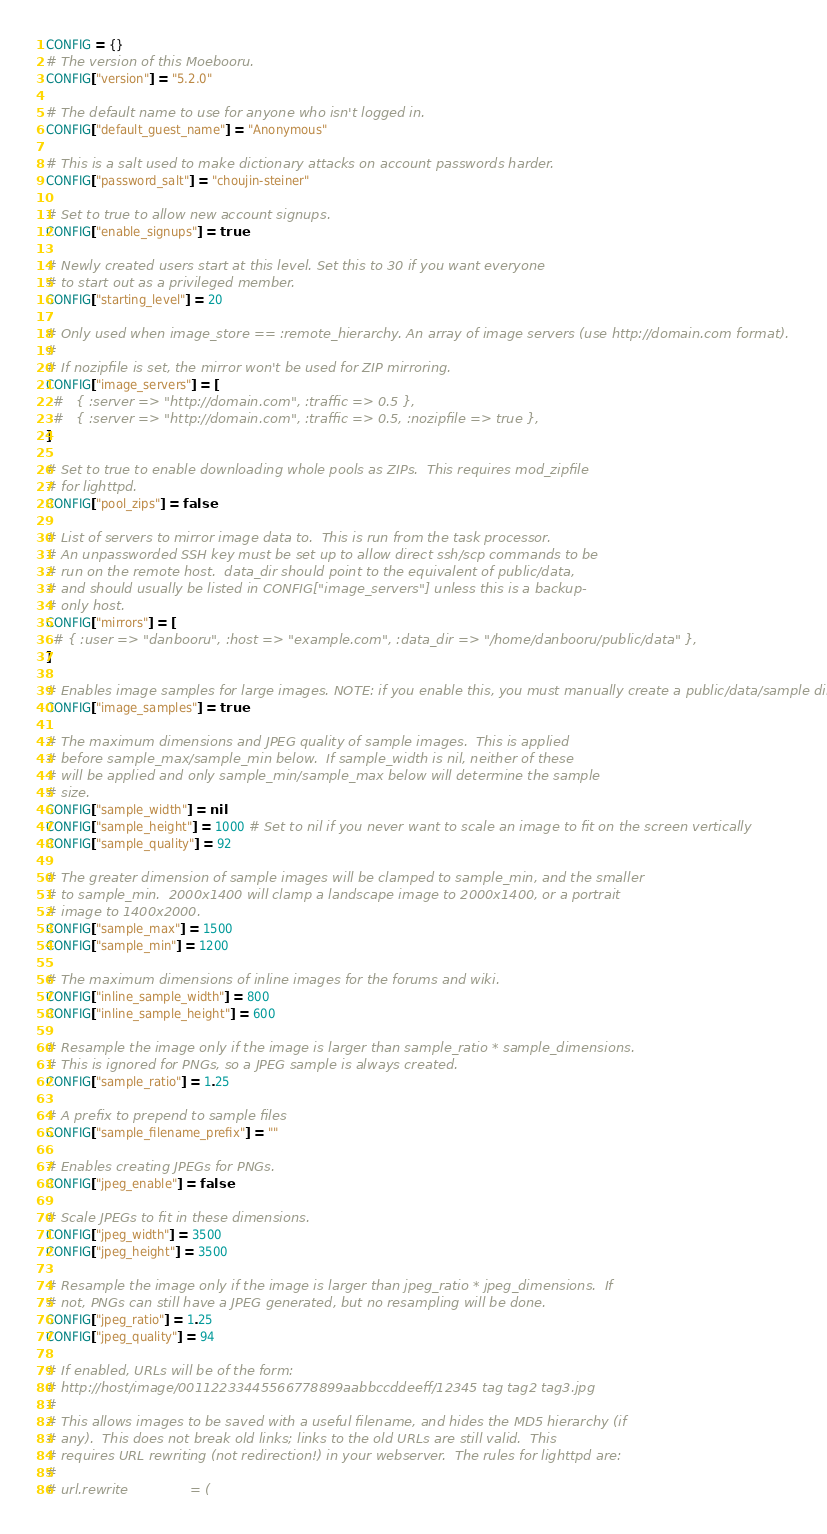<code> <loc_0><loc_0><loc_500><loc_500><_Ruby_>CONFIG = {}
# The version of this Moebooru.
CONFIG["version"] = "5.2.0"

# The default name to use for anyone who isn't logged in.
CONFIG["default_guest_name"] = "Anonymous"

# This is a salt used to make dictionary attacks on account passwords harder.
CONFIG["password_salt"] = "choujin-steiner"

# Set to true to allow new account signups.
CONFIG["enable_signups"] = true

# Newly created users start at this level. Set this to 30 if you want everyone
# to start out as a privileged member.
CONFIG["starting_level"] = 20

# Only used when image_store == :remote_hierarchy. An array of image servers (use http://domain.com format).
#
# If nozipfile is set, the mirror won't be used for ZIP mirroring.
CONFIG["image_servers"] = [
  #	{ :server => "http://domain.com", :traffic => 0.5 },
  #	{ :server => "http://domain.com", :traffic => 0.5, :nozipfile => true },
]

# Set to true to enable downloading whole pools as ZIPs.  This requires mod_zipfile
# for lighttpd.
CONFIG["pool_zips"] = false

# List of servers to mirror image data to.  This is run from the task processor.
# An unpassworded SSH key must be set up to allow direct ssh/scp commands to be
# run on the remote host.  data_dir should point to the equivalent of public/data,
# and should usually be listed in CONFIG["image_servers"] unless this is a backup-
# only host.
CONFIG["mirrors"] = [
  # { :user => "danbooru", :host => "example.com", :data_dir => "/home/danbooru/public/data" },
]

# Enables image samples for large images. NOTE: if you enable this, you must manually create a public/data/sample directory.
CONFIG["image_samples"] = true

# The maximum dimensions and JPEG quality of sample images.  This is applied
# before sample_max/sample_min below.  If sample_width is nil, neither of these
# will be applied and only sample_min/sample_max below will determine the sample
# size.
CONFIG["sample_width"] = nil
CONFIG["sample_height"] = 1000 # Set to nil if you never want to scale an image to fit on the screen vertically
CONFIG["sample_quality"] = 92

# The greater dimension of sample images will be clamped to sample_min, and the smaller
# to sample_min.  2000x1400 will clamp a landscape image to 2000x1400, or a portrait
# image to 1400x2000.
CONFIG["sample_max"] = 1500
CONFIG["sample_min"] = 1200

# The maximum dimensions of inline images for the forums and wiki.
CONFIG["inline_sample_width"] = 800
CONFIG["inline_sample_height"] = 600

# Resample the image only if the image is larger than sample_ratio * sample_dimensions.
# This is ignored for PNGs, so a JPEG sample is always created.
CONFIG["sample_ratio"] = 1.25

# A prefix to prepend to sample files
CONFIG["sample_filename_prefix"] = ""

# Enables creating JPEGs for PNGs.
CONFIG["jpeg_enable"] = false

# Scale JPEGs to fit in these dimensions.
CONFIG["jpeg_width"] = 3500
CONFIG["jpeg_height"] = 3500

# Resample the image only if the image is larger than jpeg_ratio * jpeg_dimensions.  If
# not, PNGs can still have a JPEG generated, but no resampling will be done.
CONFIG["jpeg_ratio"] = 1.25
CONFIG["jpeg_quality"] = 94

# If enabled, URLs will be of the form:
# http://host/image/00112233445566778899aabbccddeeff/12345 tag tag2 tag3.jpg
#
# This allows images to be saved with a useful filename, and hides the MD5 hierarchy (if
# any).  This does not break old links; links to the old URLs are still valid.  This
# requires URL rewriting (not redirection!) in your webserver.  The rules for lighttpd are:
#
# url.rewrite               = (</code> 